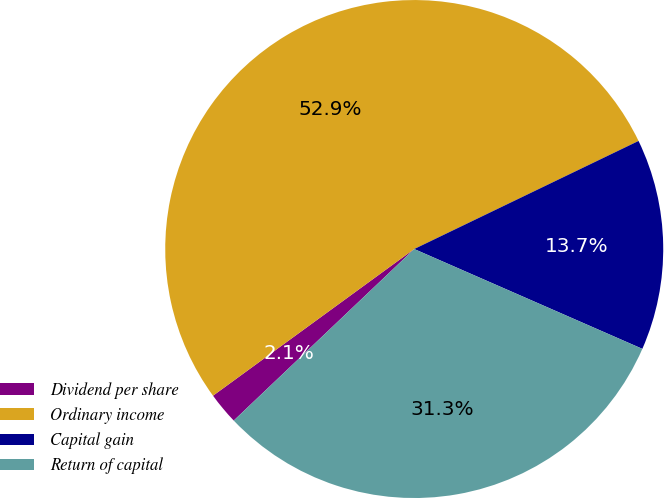Convert chart to OTSL. <chart><loc_0><loc_0><loc_500><loc_500><pie_chart><fcel>Dividend per share<fcel>Ordinary income<fcel>Capital gain<fcel>Return of capital<nl><fcel>2.07%<fcel>52.88%<fcel>13.71%<fcel>31.34%<nl></chart> 